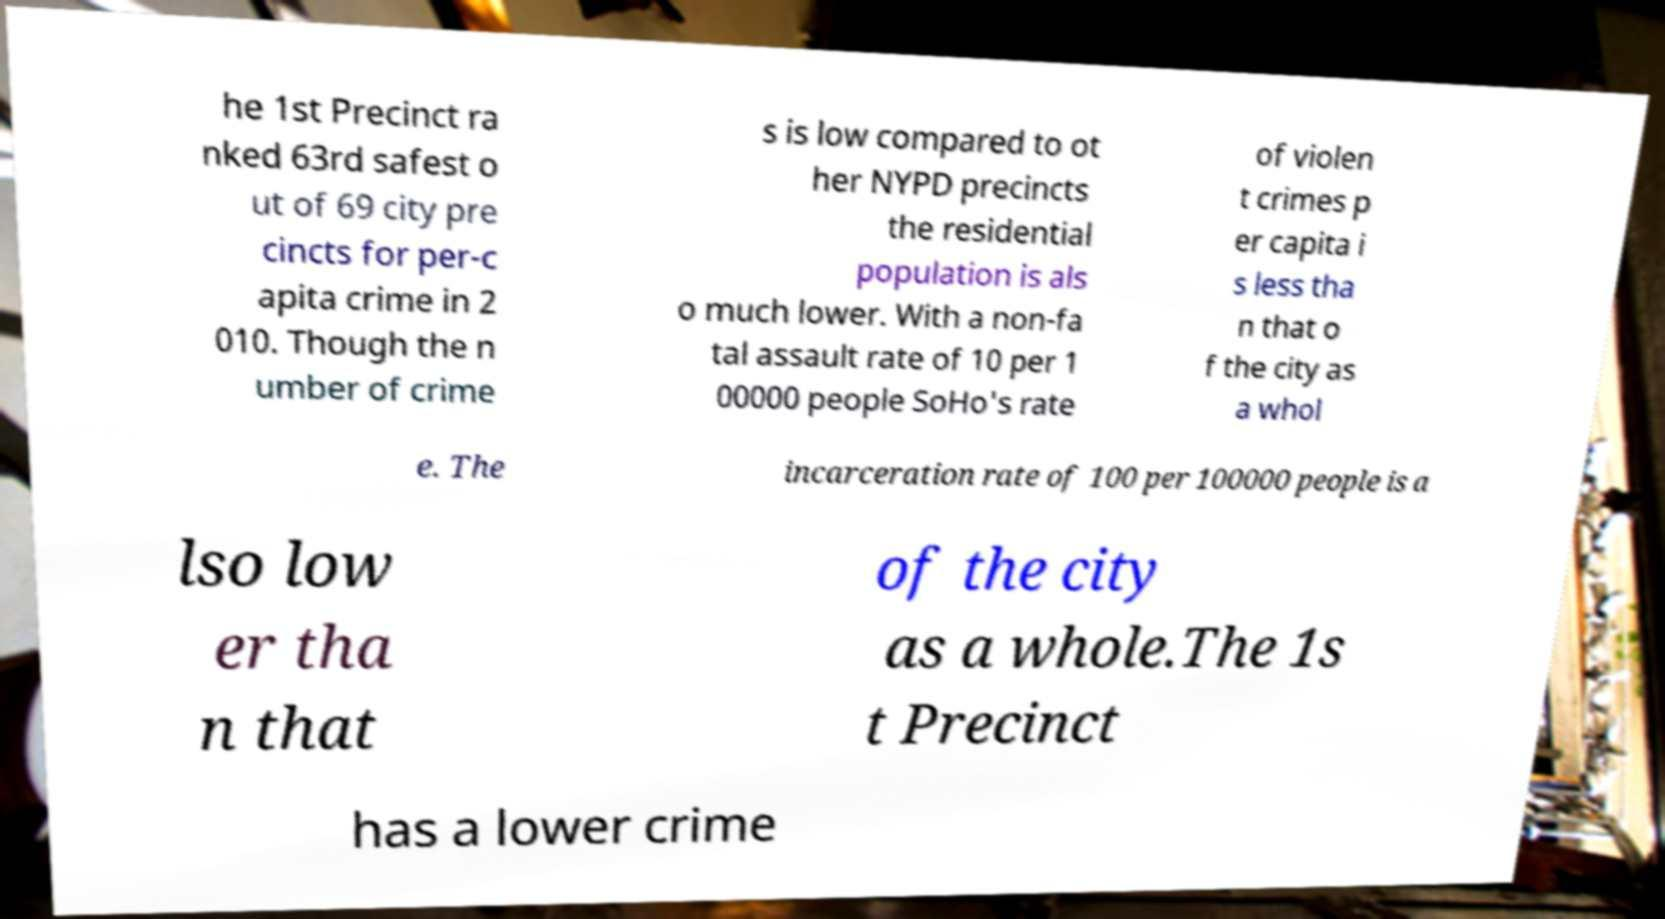What messages or text are displayed in this image? I need them in a readable, typed format. he 1st Precinct ra nked 63rd safest o ut of 69 city pre cincts for per-c apita crime in 2 010. Though the n umber of crime s is low compared to ot her NYPD precincts the residential population is als o much lower. With a non-fa tal assault rate of 10 per 1 00000 people SoHo's rate of violen t crimes p er capita i s less tha n that o f the city as a whol e. The incarceration rate of 100 per 100000 people is a lso low er tha n that of the city as a whole.The 1s t Precinct has a lower crime 